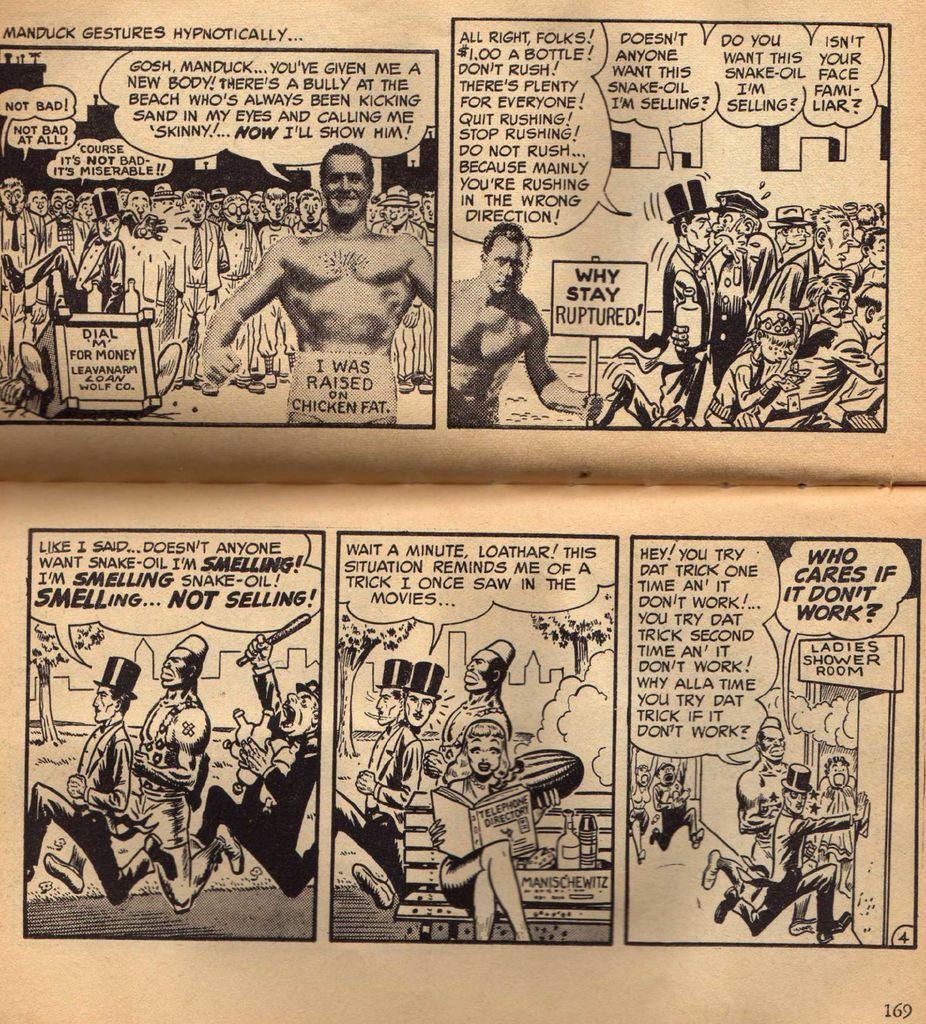Where is the man with the top hat running in the last panel?
Provide a short and direct response. Ladies shower room.  is manduck the name of this comic?
Your answer should be compact. Yes. 